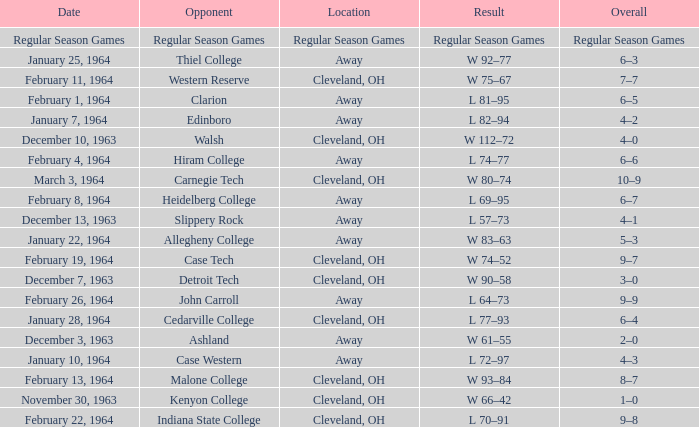Could you help me parse every detail presented in this table? {'header': ['Date', 'Opponent', 'Location', 'Result', 'Overall'], 'rows': [['Regular Season Games', 'Regular Season Games', 'Regular Season Games', 'Regular Season Games', 'Regular Season Games'], ['January 25, 1964', 'Thiel College', 'Away', 'W 92–77', '6–3'], ['February 11, 1964', 'Western Reserve', 'Cleveland, OH', 'W 75–67', '7–7'], ['February 1, 1964', 'Clarion', 'Away', 'L 81–95', '6–5'], ['January 7, 1964', 'Edinboro', 'Away', 'L 82–94', '4–2'], ['December 10, 1963', 'Walsh', 'Cleveland, OH', 'W 112–72', '4–0'], ['February 4, 1964', 'Hiram College', 'Away', 'L 74–77', '6–6'], ['March 3, 1964', 'Carnegie Tech', 'Cleveland, OH', 'W 80–74', '10–9'], ['February 8, 1964', 'Heidelberg College', 'Away', 'L 69–95', '6–7'], ['December 13, 1963', 'Slippery Rock', 'Away', 'L 57–73', '4–1'], ['January 22, 1964', 'Allegheny College', 'Away', 'W 83–63', '5–3'], ['February 19, 1964', 'Case Tech', 'Cleveland, OH', 'W 74–52', '9–7'], ['December 7, 1963', 'Detroit Tech', 'Cleveland, OH', 'W 90–58', '3–0'], ['February 26, 1964', 'John Carroll', 'Away', 'L 64–73', '9–9'], ['January 28, 1964', 'Cedarville College', 'Cleveland, OH', 'L 77–93', '6–4'], ['December 3, 1963', 'Ashland', 'Away', 'W 61–55', '2–0'], ['January 10, 1964', 'Case Western', 'Away', 'L 72–97', '4–3'], ['February 13, 1964', 'Malone College', 'Cleveland, OH', 'W 93–84', '8–7'], ['November 30, 1963', 'Kenyon College', 'Cleveland, OH', 'W 66–42', '1–0'], ['February 22, 1964', 'Indiana State College', 'Cleveland, OH', 'L 70–91', '9–8']]} What is the Date with an Opponent that is indiana state college? February 22, 1964. 